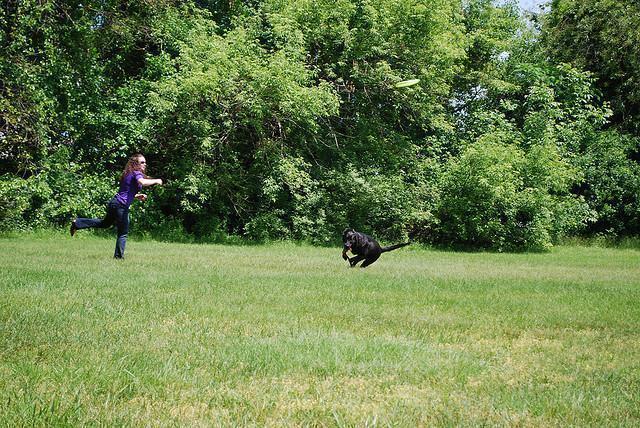What is the woman most likely to be most days of the week?
Pick the correct solution from the four options below to address the question.
Options: Spelunker, archaeologist, animal lover, princess. Animal lover. 